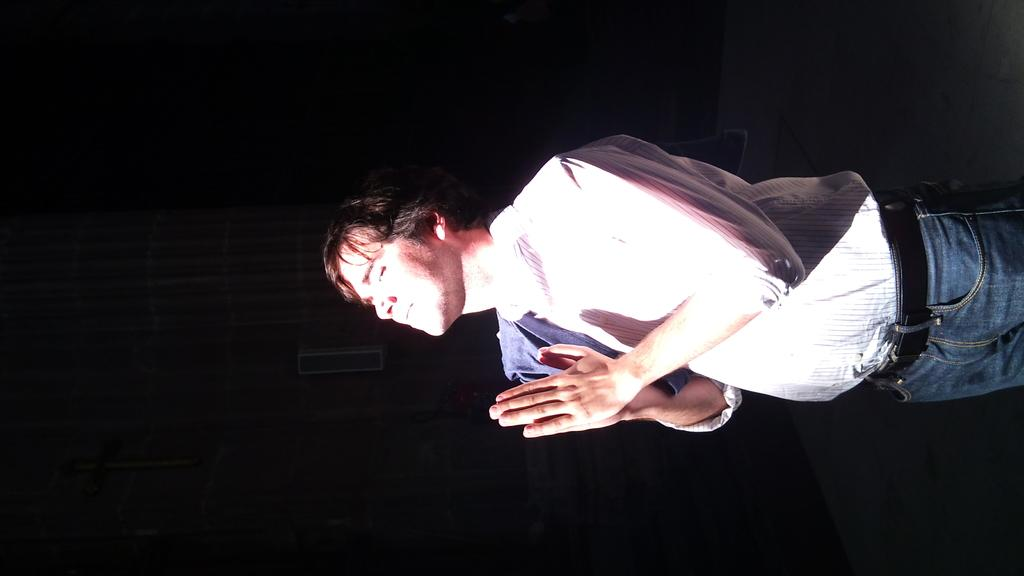What is the main subject in the foreground of the image? There is a man in the foreground of the image. What is the man doing in the image? The man is standing and closing his eyes. What activity is the man engaged in? The man is praying in the image. What can be observed about the background of the image? The background of the image is dark. What type of playground equipment can be seen in the image? There is no playground equipment present in the image. What time of day is it in the image, based on the hour? The provided facts do not mention the time of day or any specific hour, so it cannot be determined from the image. 